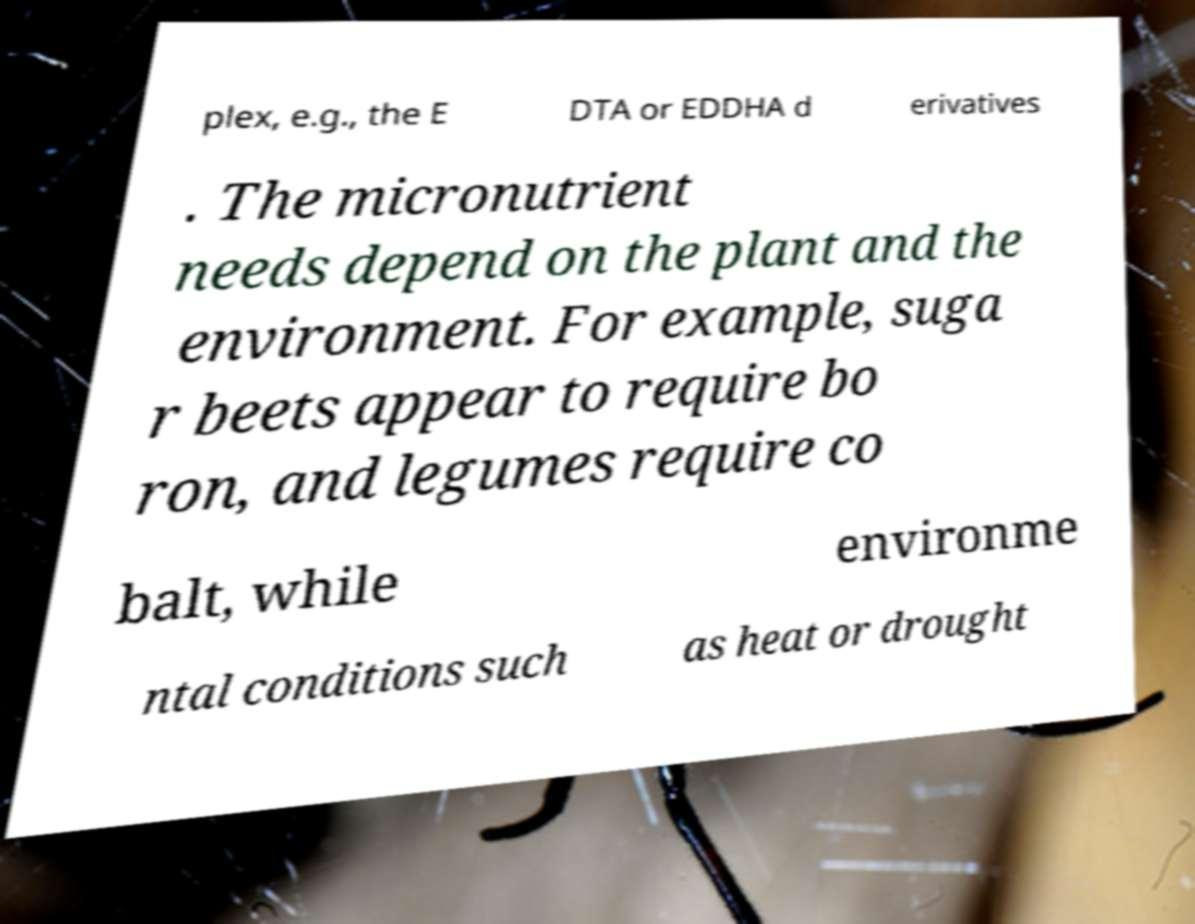Can you accurately transcribe the text from the provided image for me? plex, e.g., the E DTA or EDDHA d erivatives . The micronutrient needs depend on the plant and the environment. For example, suga r beets appear to require bo ron, and legumes require co balt, while environme ntal conditions such as heat or drought 